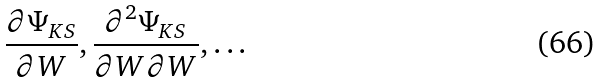Convert formula to latex. <formula><loc_0><loc_0><loc_500><loc_500>\frac { \partial \Psi _ { K S } } { \partial W } , \frac { \partial ^ { 2 } \Psi _ { K S } } { \partial W \partial W } , \dots</formula> 